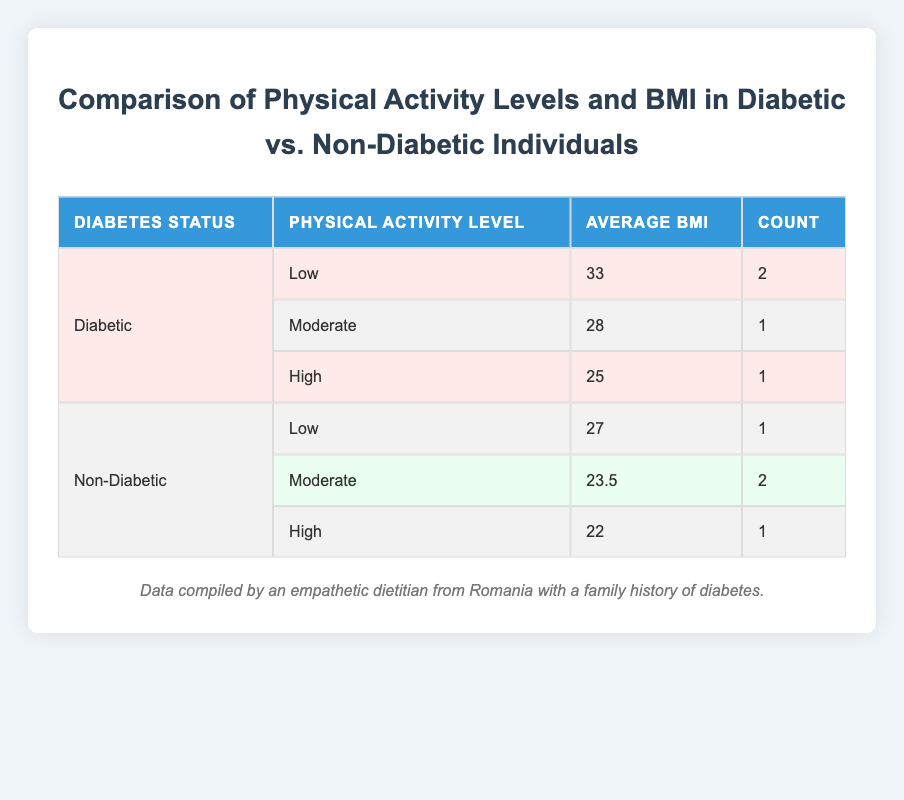What is the average BMI for diabetic individuals with a low physical activity level? From the table, there are 2 diabetic individuals listed with a low physical activity level, and their BMIs are 32 and 34. To find the average, we sum these values: 32 + 34 = 66, and then divide by the count of individuals, which is 2. Thus, the average BMI is 66 / 2 = 33.
Answer: 33 What is the BMI of the non-diabetic individual with the highest physical activity level? Looking at the non-diabetic row with a high physical activity level, there is one individual with a BMI of 22. Since this is the only entry listed under high physical activity, it automatically has the highest BMI.
Answer: 22 Are there more individuals with a moderate physical activity level in the non-diabetic group or the diabetic group? The table shows that there are 2 non-diabetic individuals with a moderate physical activity level (with average BMI 23.5) and 1 diabetic individual with a moderate physical activity level (with BMI 28). Since 2 is greater than 1, the non-diabetic group has more individuals with moderate physical activity level.
Answer: Non-diabetic group What is the difference in average BMI between diabetic individuals with low vs. high physical activity levels? The average BMI for diabetic individuals with low physical activity is 33, while the average BMI for those with high physical activity is 25. To find the difference, we subtract the average BMI of high activity from that of low activity: 33 - 25 = 8.
Answer: 8 Is it true that all individuals with a high physical activity level have a BMI below 30? From the data, the high physical activity level BMI values are 25 for diabetics and 22 for non-diabetics. Both are indeed below 30; therefore, the statement is true.
Answer: Yes 